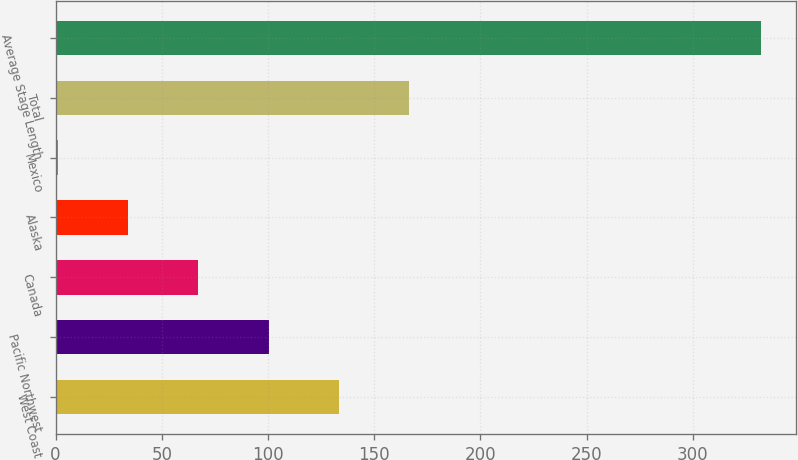Convert chart. <chart><loc_0><loc_0><loc_500><loc_500><bar_chart><fcel>West Coast<fcel>Pacific Northwest<fcel>Canada<fcel>Alaska<fcel>Mexico<fcel>Total<fcel>Average Stage Length<nl><fcel>133.4<fcel>100.3<fcel>67.2<fcel>34.1<fcel>1<fcel>166.5<fcel>332<nl></chart> 